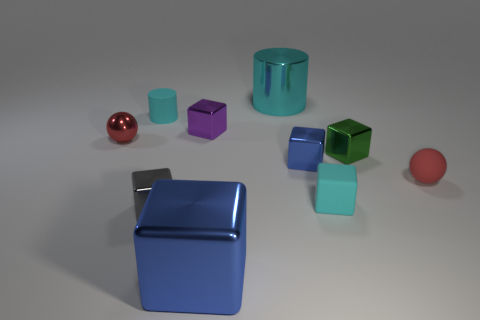Is the shape of the purple object the same as the large cyan thing?
Make the answer very short. No. How big is the red ball that is behind the red ball that is right of the small rubber object that is on the left side of the tiny gray metal object?
Your response must be concise. Small. What material is the cyan object that is the same shape as the small green thing?
Provide a short and direct response. Rubber. Are there any other things that are the same size as the red rubber ball?
Your answer should be very brief. Yes. What is the size of the blue shiny cube right of the big object that is behind the purple thing?
Your answer should be compact. Small. What is the color of the metal ball?
Your response must be concise. Red. What number of small gray blocks are to the left of the cylinder to the right of the big blue metallic object?
Offer a terse response. 1. There is a small block that is behind the green metal thing; are there any tiny blue metal things that are behind it?
Make the answer very short. No. Are there any big metallic things in front of the purple metal block?
Provide a succinct answer. Yes. Does the red object that is right of the small red metal thing have the same shape as the big blue metal object?
Give a very brief answer. No. 